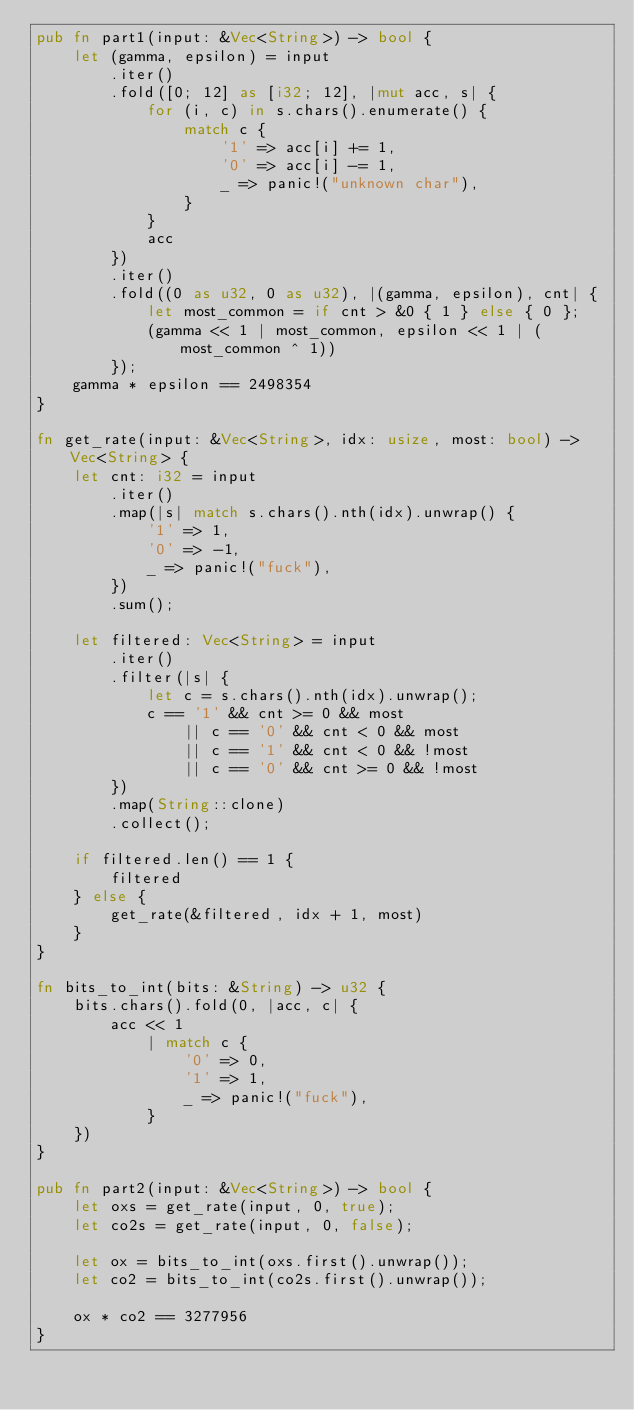Convert code to text. <code><loc_0><loc_0><loc_500><loc_500><_Rust_>pub fn part1(input: &Vec<String>) -> bool {
    let (gamma, epsilon) = input
        .iter()
        .fold([0; 12] as [i32; 12], |mut acc, s| {
            for (i, c) in s.chars().enumerate() {
                match c {
                    '1' => acc[i] += 1,
                    '0' => acc[i] -= 1,
                    _ => panic!("unknown char"),
                }
            }
            acc
        })
        .iter()
        .fold((0 as u32, 0 as u32), |(gamma, epsilon), cnt| {
            let most_common = if cnt > &0 { 1 } else { 0 };
            (gamma << 1 | most_common, epsilon << 1 | (most_common ^ 1))
        });
    gamma * epsilon == 2498354
}

fn get_rate(input: &Vec<String>, idx: usize, most: bool) -> Vec<String> {
    let cnt: i32 = input
        .iter()
        .map(|s| match s.chars().nth(idx).unwrap() {
            '1' => 1,
            '0' => -1,
            _ => panic!("fuck"),
        })
        .sum();

    let filtered: Vec<String> = input
        .iter()
        .filter(|s| {
            let c = s.chars().nth(idx).unwrap();
            c == '1' && cnt >= 0 && most
                || c == '0' && cnt < 0 && most
                || c == '1' && cnt < 0 && !most
                || c == '0' && cnt >= 0 && !most
        })
        .map(String::clone)
        .collect();

    if filtered.len() == 1 {
        filtered
    } else {
        get_rate(&filtered, idx + 1, most)
    }
}

fn bits_to_int(bits: &String) -> u32 {
    bits.chars().fold(0, |acc, c| {
        acc << 1
            | match c {
                '0' => 0,
                '1' => 1,
                _ => panic!("fuck"),
            }
    })
}

pub fn part2(input: &Vec<String>) -> bool {
    let oxs = get_rate(input, 0, true);
    let co2s = get_rate(input, 0, false);

    let ox = bits_to_int(oxs.first().unwrap());
    let co2 = bits_to_int(co2s.first().unwrap());

    ox * co2 == 3277956
}
</code> 